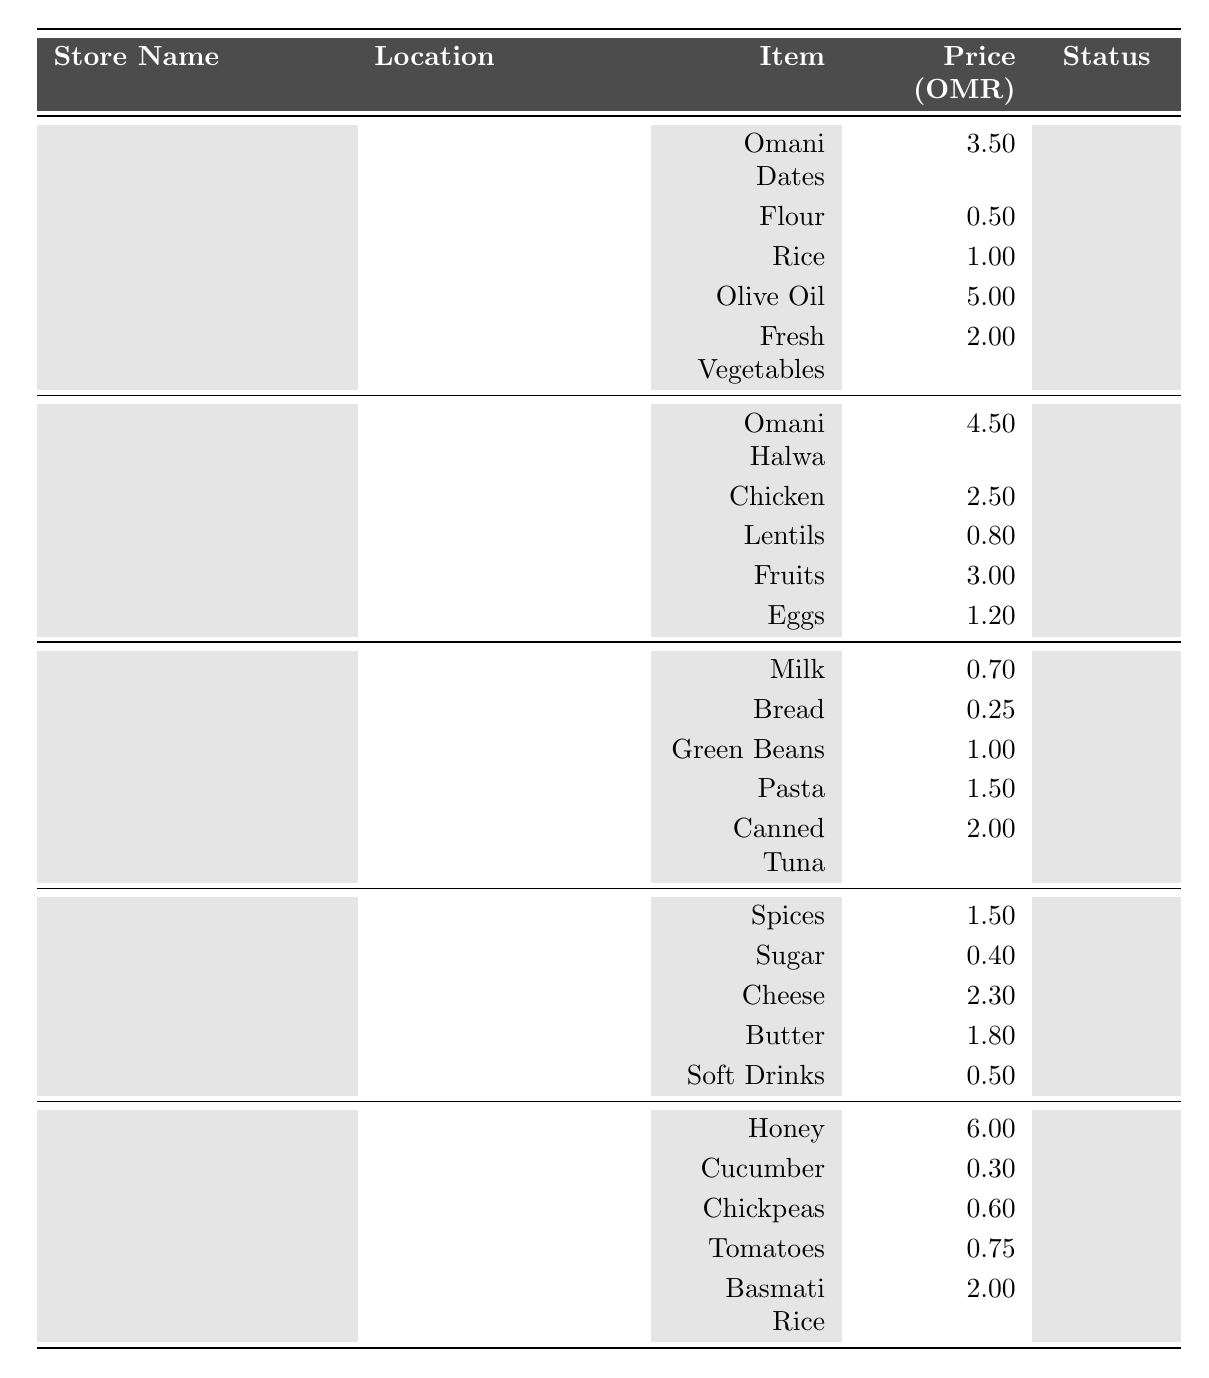What is the overall status of Safa Supermarket? The table indicates that Safa Supermarket has an overall status listed as "Good" in the appropriate column.
Answer: Good How many Omani Dates are available at Al-Falahi Grocery? According to the table, Al-Falahi Grocery has 200 Omani Dates available, as recorded in the inventory items.
Answer: 200 Which item has the highest price at Oman Traditional Mart? By reviewing the prices listed for each item at Oman Traditional Mart, Honey at 6.00 OMR is the highest price compared to other items.
Answer: Honey What is the total quantity of items available at Muscat Fresh Market? The total quantity of items at Muscat Fresh Market can be calculated by summing the quantities: 50 (Omani Halwa) + 80 (Chicken) + 30 (Lentils) + 90 (Fruits) + 60 (Eggs) = 310.
Answer: 310 Is there any store with a low overall status? The table shows that Al-Dhahirah Grocery has an overall status marked as "Low," confirming that there is at least one store with a low status.
Answer: Yes Which store is located in Ghubra? The table specifies that Oman Traditional Mart is located in Ghubra, as indicated in the location column.
Answer: Oman Traditional Mart How many different items does Al-Falahi Grocery have for sale? Al-Falahi Grocery's inventory lists five different items, including Omani Dates, Flour, Rice, Olive Oil, and Fresh Vegetables.
Answer: 5 What is the combined quantity of Fresh Vegetables and Canned Tuna at their respective stores? Fresh Vegetables at Al-Falahi Grocery has a quantity of 120, and Canned Tuna at Safa Supermarket has a quantity of 45. Adding these gives us 120 + 45 = 165.
Answer: 165 Which store has the most stable inventory status? The table indicates that both Al-Falahi Grocery and Oman Traditional Mart have an overall status of "Stable." Therefore, they both exhibit a stable inventory status.
Answer: Al-Falahi Grocery and Oman Traditional Mart What is the average price of items at Al-Dhahirah Grocery? Average price is calculated by adding the prices of items: (1.5 + 0.4 + 2.3 + 1.8 + 0.5) = 6.5 OMR, then divided by 5 items, resulting in 6.5 / 5 = 1.3 OMR.
Answer: 1.3 OMR 